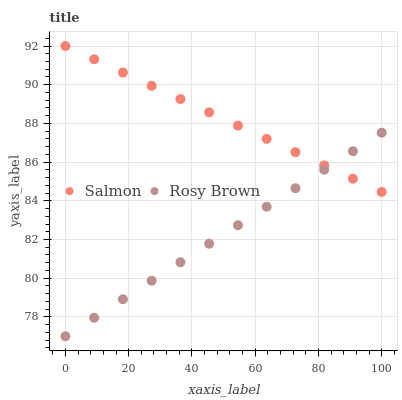Does Rosy Brown have the minimum area under the curve?
Answer yes or no. Yes. Does Salmon have the maximum area under the curve?
Answer yes or no. Yes. Does Salmon have the minimum area under the curve?
Answer yes or no. No. Is Salmon the smoothest?
Answer yes or no. Yes. Is Rosy Brown the roughest?
Answer yes or no. Yes. Is Salmon the roughest?
Answer yes or no. No. Does Rosy Brown have the lowest value?
Answer yes or no. Yes. Does Salmon have the lowest value?
Answer yes or no. No. Does Salmon have the highest value?
Answer yes or no. Yes. Does Rosy Brown intersect Salmon?
Answer yes or no. Yes. Is Rosy Brown less than Salmon?
Answer yes or no. No. Is Rosy Brown greater than Salmon?
Answer yes or no. No. 